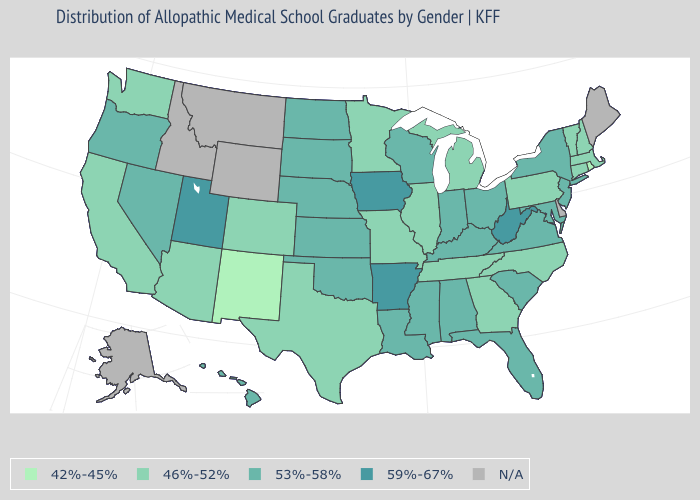How many symbols are there in the legend?
Quick response, please. 5. Name the states that have a value in the range N/A?
Answer briefly. Alaska, Delaware, Idaho, Maine, Montana, Wyoming. What is the value of Virginia?
Give a very brief answer. 53%-58%. What is the lowest value in the South?
Short answer required. 46%-52%. Name the states that have a value in the range 59%-67%?
Keep it brief. Arkansas, Iowa, Utah, West Virginia. What is the value of New Mexico?
Keep it brief. 42%-45%. Among the states that border New York , which have the highest value?
Give a very brief answer. New Jersey. Name the states that have a value in the range 46%-52%?
Give a very brief answer. Arizona, California, Colorado, Connecticut, Georgia, Illinois, Massachusetts, Michigan, Minnesota, Missouri, New Hampshire, North Carolina, Pennsylvania, Tennessee, Texas, Vermont, Washington. What is the value of Iowa?
Be succinct. 59%-67%. What is the lowest value in states that border Pennsylvania?
Write a very short answer. 53%-58%. Does North Carolina have the lowest value in the South?
Concise answer only. Yes. How many symbols are there in the legend?
Write a very short answer. 5. What is the value of Alabama?
Keep it brief. 53%-58%. 